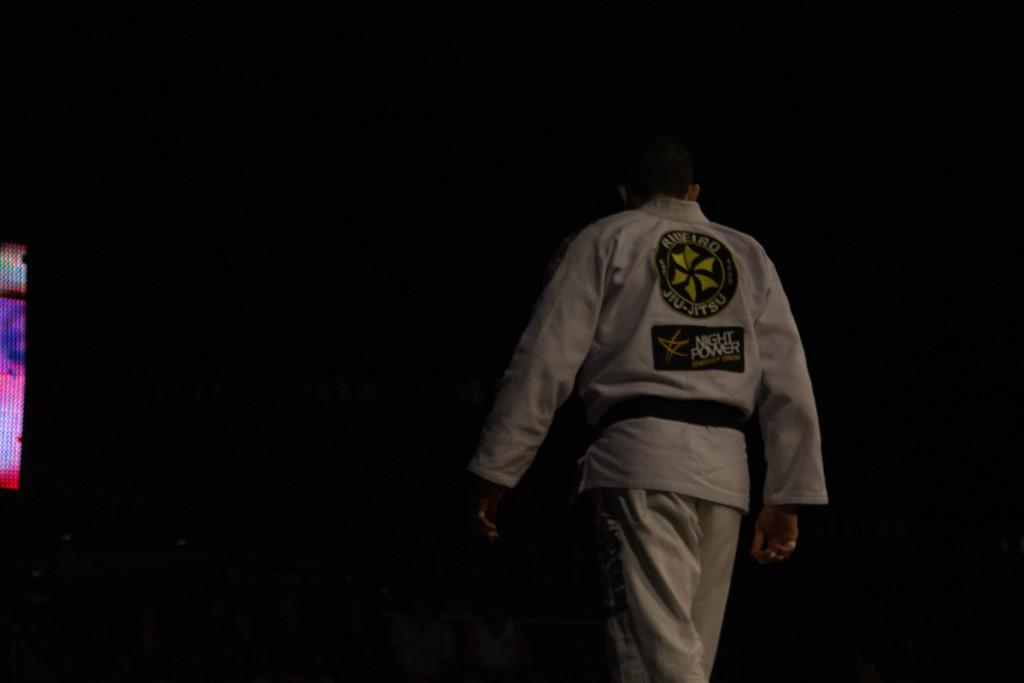Provide a one-sentence caption for the provided image. a person with their back to the camera in a suit reading Jiu-Jitsu. 